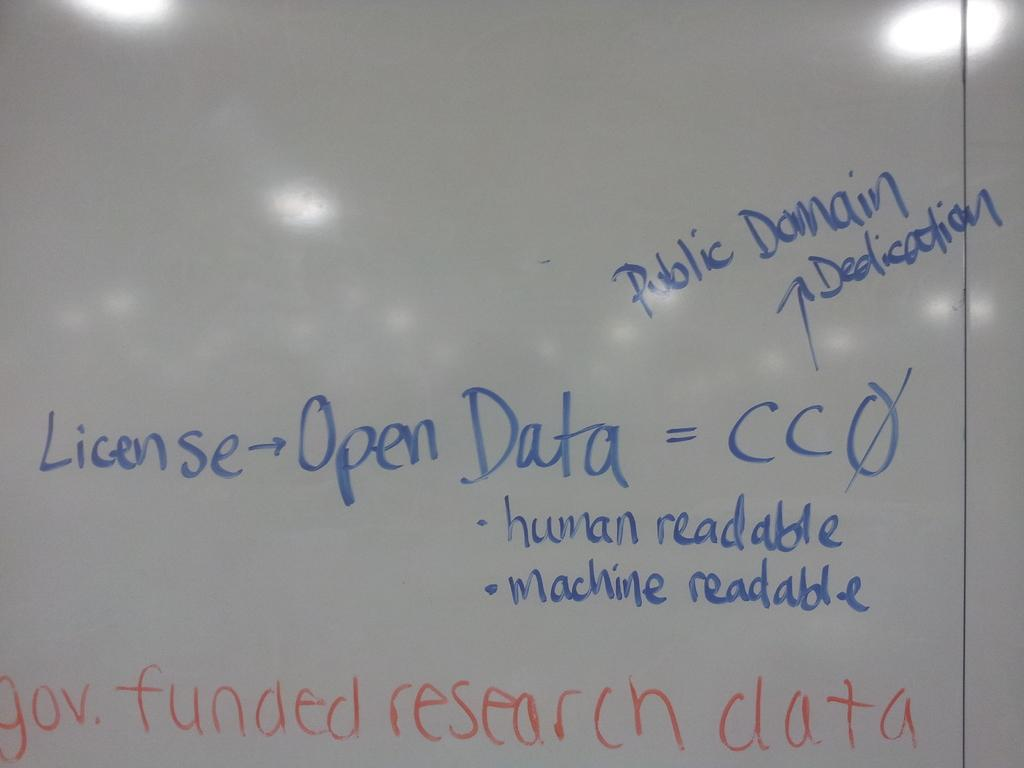Provide a one-sentence caption for the provided image. Government funded research data requires a license for access but is then both human and machine readable. 